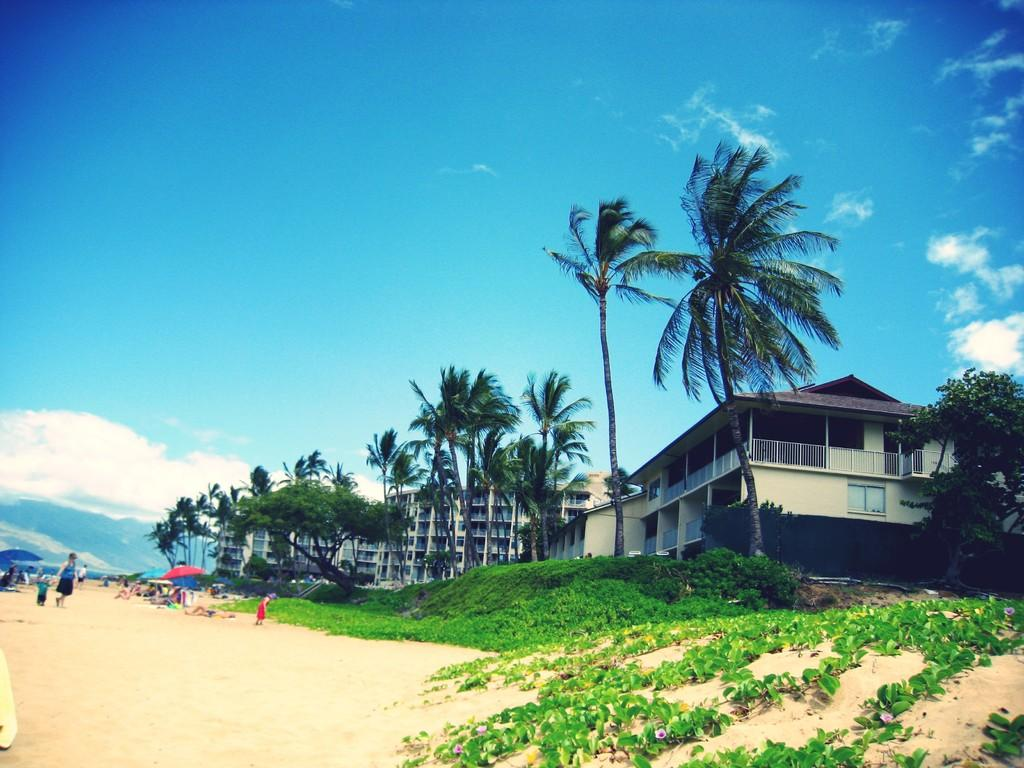What is located in the front of the image? There are plants in the front of the image. What can be seen in the background of the image? There are persons, tents, trees, and buildings in the background of the image. What is the condition of the sky in the image? The sky is cloudy in the image. How many apples are being held by the girls in the image? There are no girls present in the image, and therefore no apples can be observed. What type of ice can be seen melting on the plants in the image? There is no ice present in the image; it features plants, persons, tents, trees, buildings, and a cloudy sky. 